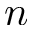Convert formula to latex. <formula><loc_0><loc_0><loc_500><loc_500>n</formula> 